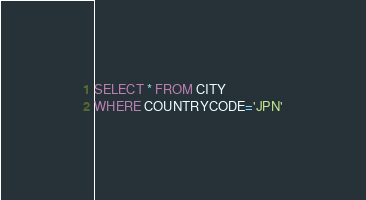<code> <loc_0><loc_0><loc_500><loc_500><_SQL_>SELECT * FROM CITY
WHERE COUNTRYCODE='JPN'</code> 